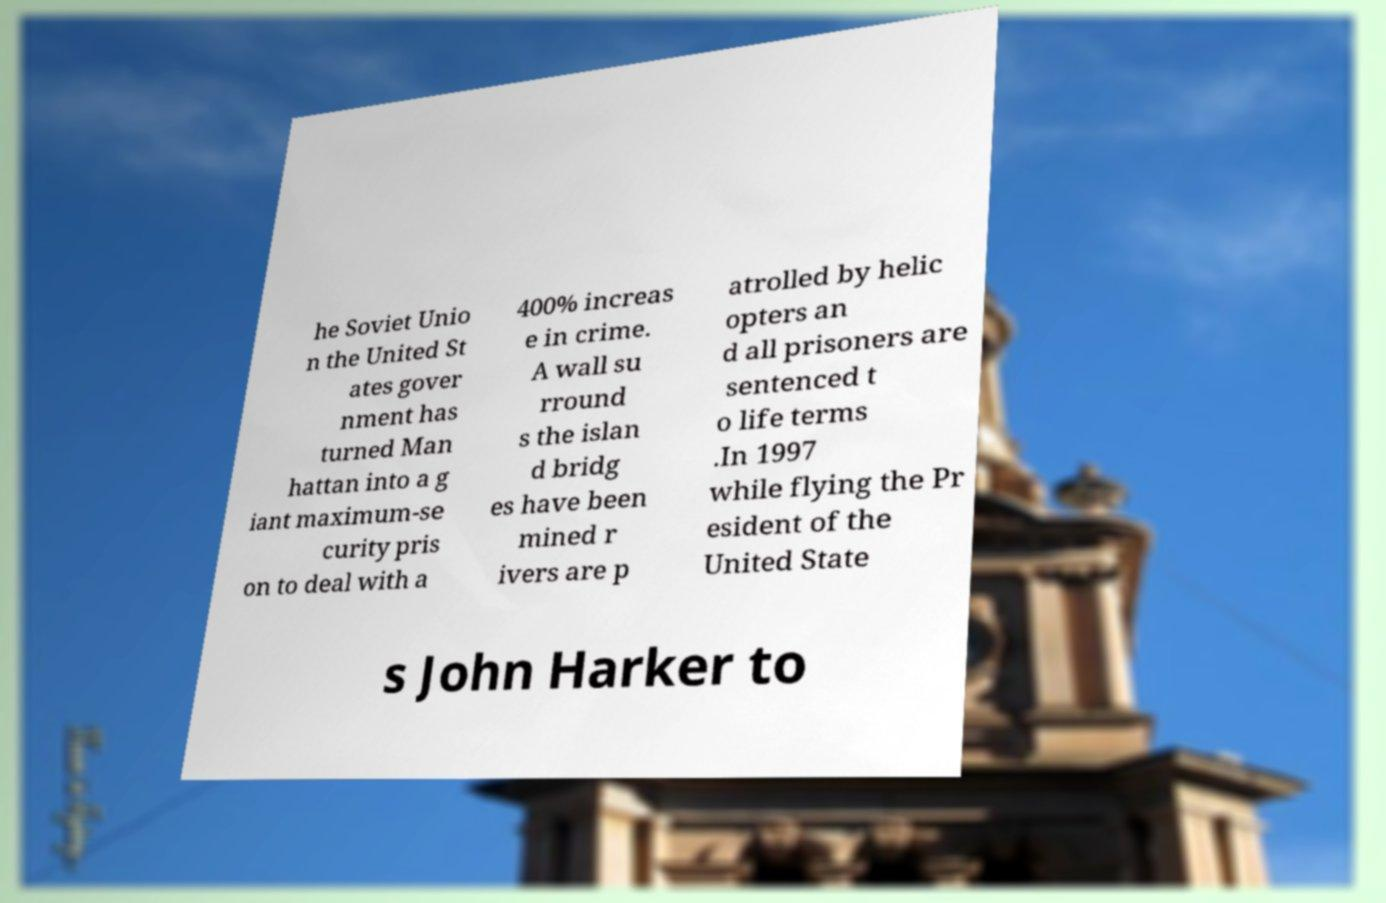Can you accurately transcribe the text from the provided image for me? he Soviet Unio n the United St ates gover nment has turned Man hattan into a g iant maximum-se curity pris on to deal with a 400% increas e in crime. A wall su rround s the islan d bridg es have been mined r ivers are p atrolled by helic opters an d all prisoners are sentenced t o life terms .In 1997 while flying the Pr esident of the United State s John Harker to 